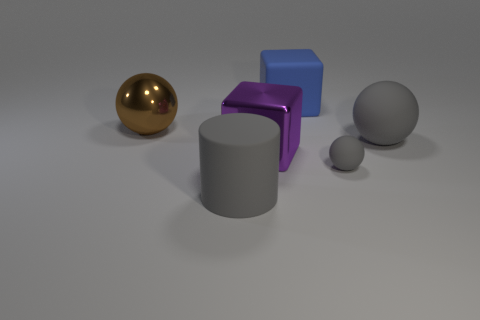Is the size of the metallic thing that is right of the brown sphere the same as the tiny sphere?
Provide a succinct answer. No. Is the number of large gray metallic balls greater than the number of big balls?
Offer a terse response. No. How many tiny objects are gray metal balls or gray matte things?
Provide a short and direct response. 1. What number of other things are the same color as the rubber block?
Ensure brevity in your answer.  0. How many large cylinders have the same material as the big purple thing?
Your response must be concise. 0. There is a object in front of the small gray sphere; is its color the same as the shiny cube?
Make the answer very short. No. What number of blue objects are large blocks or matte balls?
Provide a short and direct response. 1. Are there any other things that are the same material as the large brown thing?
Your answer should be compact. Yes. Are the large gray object that is on the right side of the large purple metallic object and the big brown object made of the same material?
Your answer should be very brief. No. What number of objects are large purple objects or large rubber things that are behind the purple object?
Your answer should be compact. 3. 